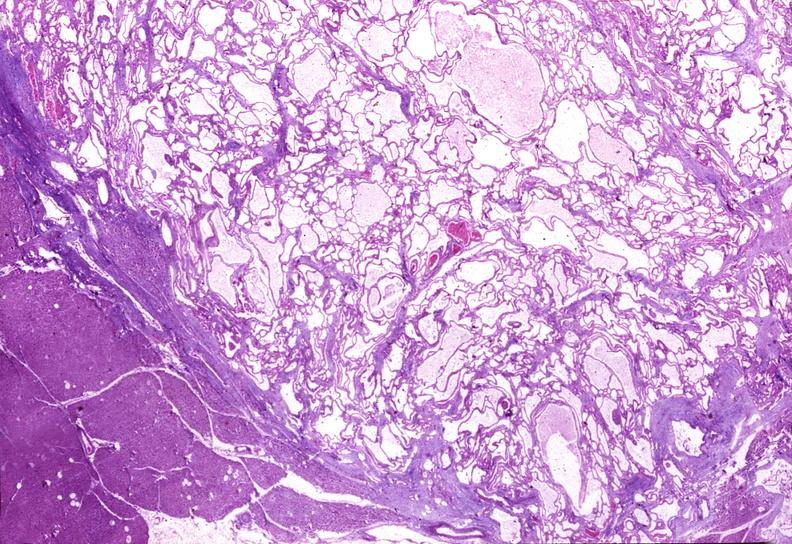where is this?
Answer the question using a single word or phrase. Pancreas 